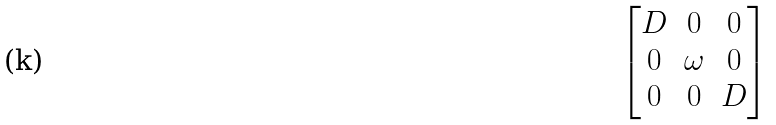Convert formula to latex. <formula><loc_0><loc_0><loc_500><loc_500>\begin{bmatrix} D & 0 & 0 \\ 0 & \omega & 0 \\ 0 & 0 & D \end{bmatrix}</formula> 